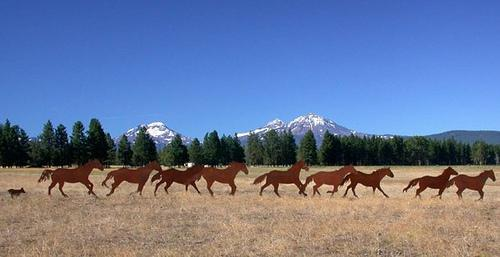Count the number of horses in the image and describe their movement. There are nine horses running to the right, in motion. Identify the interactions between the animals in the image. A dog is chasing after horses that are running together as a herd. How many trees are explicitly mentioned in the image, and which one is the tallest? There are no trees explicitly mentioned in the image. Describe the background of this image, including the mountains and sky. There are snow-covered mountain peaks and a crystal blue sky in the background. Evaluate the quality of the image based on the provided details. The image seems lively and vivid, capturing the movement and scenery well. What breed of dog is featured in the image, and what color is it? A brown dog, breed unspecified, running behind the horses. Specify the type of trees in the image and the color of the grass in the field. There are no trees visible in the image; the grass in the field is dry and golden. Using complex reasoning, deduce what the overall theme of the image might be. The image evokes a sense of the harmony and struggle between animals and nature. What is the primary focus of the image and what are they doing? Horses running in a field, with a dog chasing them. In a few words, express the overall sentiment or emotion conveyed by the image. Freedom, excitement, and the beauty of nature. 